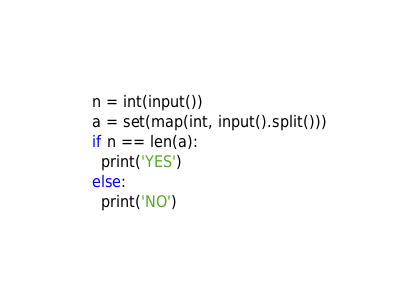Convert code to text. <code><loc_0><loc_0><loc_500><loc_500><_Python_>n = int(input())
a = set(map(int, input().split()))
if n == len(a):
  print('YES')
else:
  print('NO')</code> 